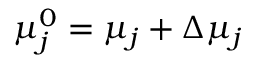<formula> <loc_0><loc_0><loc_500><loc_500>\mu _ { j } ^ { 0 } = \mu _ { j } + \Delta \mu _ { j }</formula> 